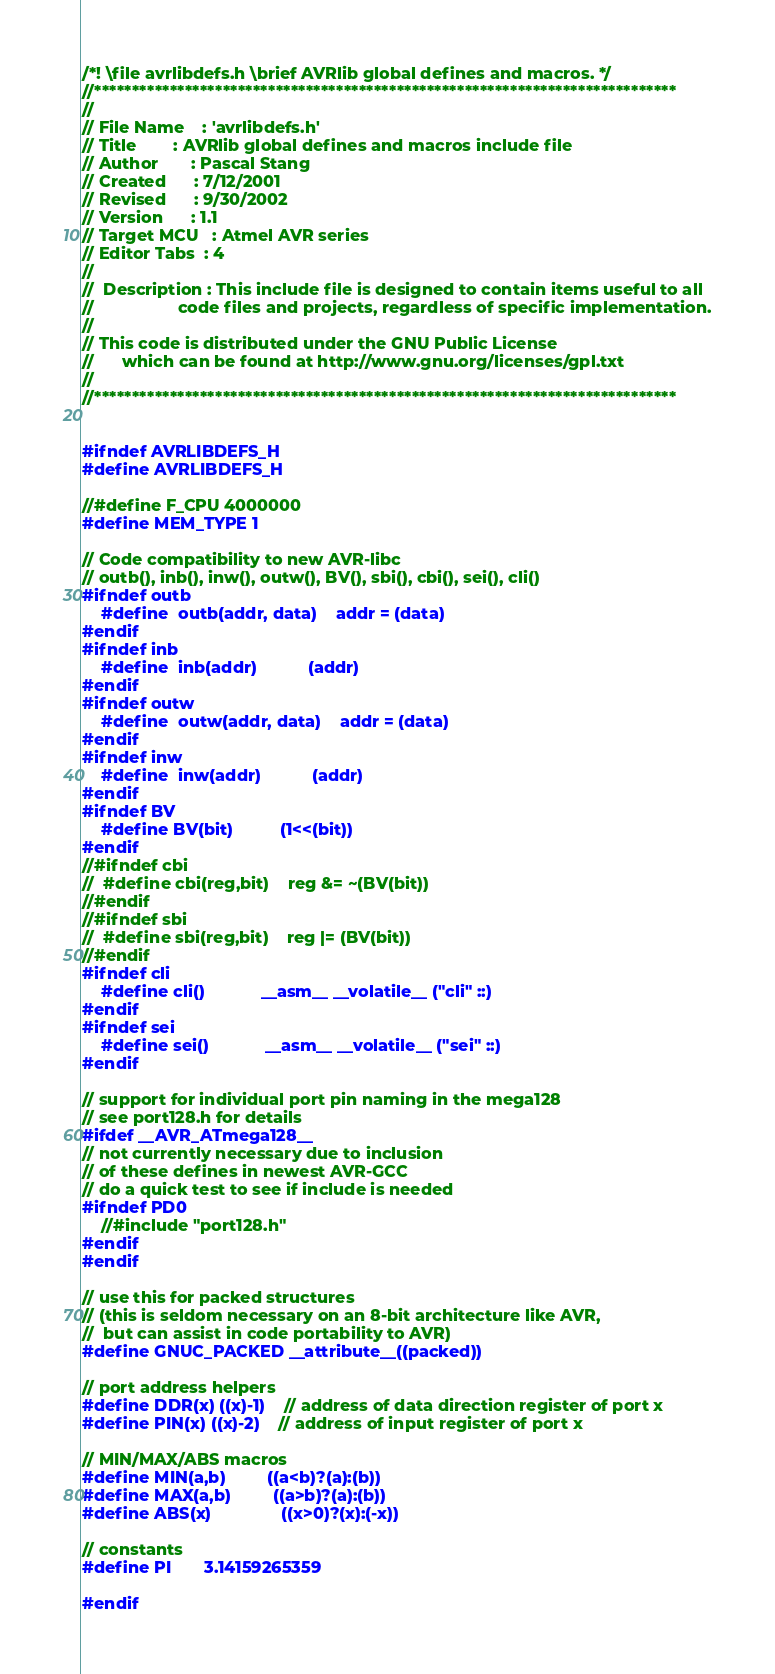<code> <loc_0><loc_0><loc_500><loc_500><_C_>/*! \file avrlibdefs.h \brief AVRlib global defines and macros. */
//*****************************************************************************
//
// File Name	: 'avrlibdefs.h'
// Title		: AVRlib global defines and macros include file
// Author		: Pascal Stang
// Created		: 7/12/2001
// Revised		: 9/30/2002
// Version		: 1.1
// Target MCU	: Atmel AVR series
// Editor Tabs	: 4
//
//	Description : This include file is designed to contain items useful to all
//					code files and projects, regardless of specific implementation.
//
// This code is distributed under the GNU Public License
//		which can be found at http://www.gnu.org/licenses/gpl.txt
//
//*****************************************************************************


#ifndef AVRLIBDEFS_H
#define AVRLIBDEFS_H

//#define F_CPU 4000000
#define MEM_TYPE 1

// Code compatibility to new AVR-libc
// outb(), inb(), inw(), outw(), BV(), sbi(), cbi(), sei(), cli()
#ifndef outb
	#define	outb(addr, data)	addr = (data)
#endif
#ifndef inb
	#define	inb(addr)			(addr)
#endif
#ifndef outw
	#define	outw(addr, data)	addr = (data)
#endif
#ifndef inw
	#define	inw(addr)			(addr)
#endif
#ifndef BV
	#define BV(bit)			(1<<(bit))
#endif
//#ifndef cbi
//	#define cbi(reg,bit)	reg &= ~(BV(bit))
//#endif
//#ifndef sbi
//	#define sbi(reg,bit)	reg |= (BV(bit))
//#endif
#ifndef cli
	#define cli()			__asm__ __volatile__ ("cli" ::)
#endif
#ifndef sei
	#define sei()			__asm__ __volatile__ ("sei" ::)
#endif

// support for individual port pin naming in the mega128
// see port128.h for details
#ifdef __AVR_ATmega128__
// not currently necessary due to inclusion
// of these defines in newest AVR-GCC
// do a quick test to see if include is needed
#ifndef PD0
	//#include "port128.h"
#endif
#endif

// use this for packed structures
// (this is seldom necessary on an 8-bit architecture like AVR,
//  but can assist in code portability to AVR)
#define GNUC_PACKED __attribute__((packed)) 

// port address helpers
#define DDR(x) ((x)-1)    // address of data direction register of port x
#define PIN(x) ((x)-2)    // address of input register of port x

// MIN/MAX/ABS macros
#define MIN(a,b)			((a<b)?(a):(b))
#define MAX(a,b)			((a>b)?(a):(b))
#define ABS(x)				((x>0)?(x):(-x))

// constants
#define PI		3.14159265359

#endif
</code> 